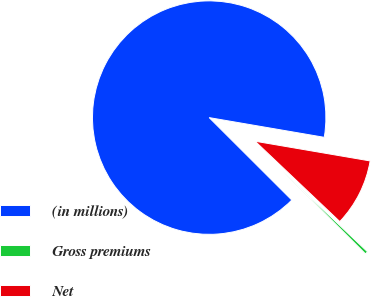<chart> <loc_0><loc_0><loc_500><loc_500><pie_chart><fcel>(in millions)<fcel>Gross premiums<fcel>Net<nl><fcel>90.21%<fcel>0.4%<fcel>9.38%<nl></chart> 